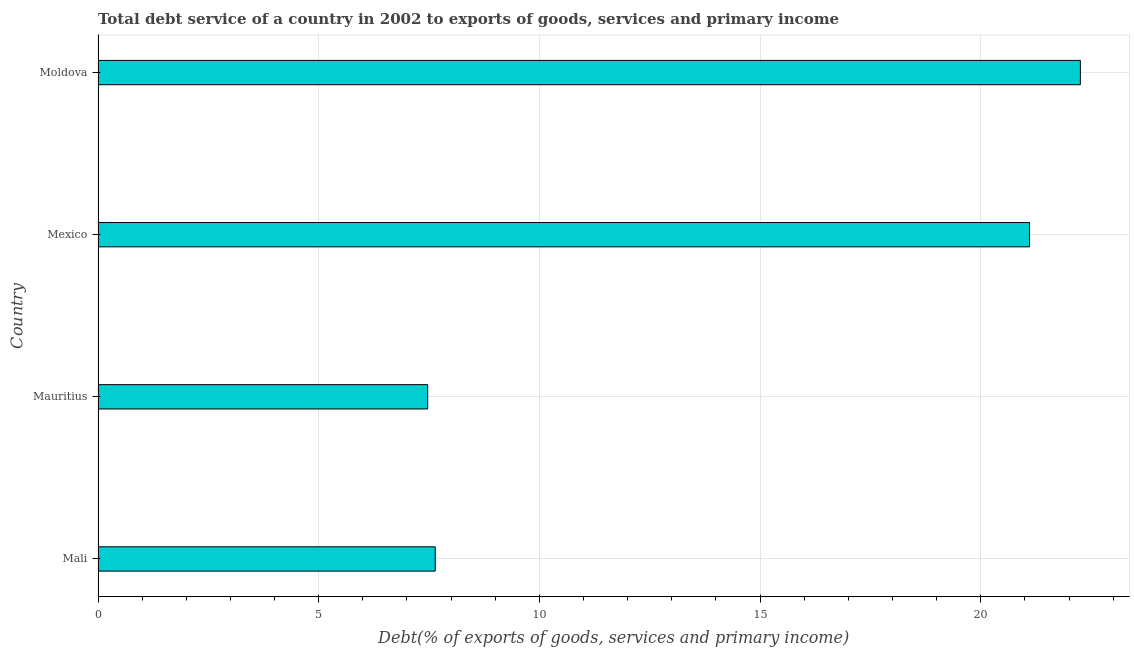Does the graph contain grids?
Give a very brief answer. Yes. What is the title of the graph?
Ensure brevity in your answer.  Total debt service of a country in 2002 to exports of goods, services and primary income. What is the label or title of the X-axis?
Your response must be concise. Debt(% of exports of goods, services and primary income). What is the total debt service in Mali?
Make the answer very short. 7.64. Across all countries, what is the maximum total debt service?
Offer a terse response. 22.26. Across all countries, what is the minimum total debt service?
Give a very brief answer. 7.47. In which country was the total debt service maximum?
Keep it short and to the point. Moldova. In which country was the total debt service minimum?
Give a very brief answer. Mauritius. What is the sum of the total debt service?
Keep it short and to the point. 58.47. What is the difference between the total debt service in Mali and Moldova?
Ensure brevity in your answer.  -14.62. What is the average total debt service per country?
Provide a short and direct response. 14.62. What is the median total debt service?
Give a very brief answer. 14.37. In how many countries, is the total debt service greater than 8 %?
Provide a succinct answer. 2. What is the ratio of the total debt service in Mauritius to that in Moldova?
Your response must be concise. 0.34. Is the difference between the total debt service in Mali and Moldova greater than the difference between any two countries?
Keep it short and to the point. No. What is the difference between the highest and the second highest total debt service?
Your answer should be very brief. 1.15. What is the difference between the highest and the lowest total debt service?
Provide a short and direct response. 14.79. Are all the bars in the graph horizontal?
Make the answer very short. Yes. How many countries are there in the graph?
Your response must be concise. 4. What is the difference between two consecutive major ticks on the X-axis?
Your answer should be very brief. 5. Are the values on the major ticks of X-axis written in scientific E-notation?
Offer a terse response. No. What is the Debt(% of exports of goods, services and primary income) in Mali?
Give a very brief answer. 7.64. What is the Debt(% of exports of goods, services and primary income) in Mauritius?
Your answer should be very brief. 7.47. What is the Debt(% of exports of goods, services and primary income) of Mexico?
Give a very brief answer. 21.11. What is the Debt(% of exports of goods, services and primary income) in Moldova?
Ensure brevity in your answer.  22.26. What is the difference between the Debt(% of exports of goods, services and primary income) in Mali and Mauritius?
Give a very brief answer. 0.17. What is the difference between the Debt(% of exports of goods, services and primary income) in Mali and Mexico?
Give a very brief answer. -13.47. What is the difference between the Debt(% of exports of goods, services and primary income) in Mali and Moldova?
Your answer should be compact. -14.62. What is the difference between the Debt(% of exports of goods, services and primary income) in Mauritius and Mexico?
Ensure brevity in your answer.  -13.64. What is the difference between the Debt(% of exports of goods, services and primary income) in Mauritius and Moldova?
Keep it short and to the point. -14.79. What is the difference between the Debt(% of exports of goods, services and primary income) in Mexico and Moldova?
Make the answer very short. -1.15. What is the ratio of the Debt(% of exports of goods, services and primary income) in Mali to that in Mauritius?
Your response must be concise. 1.02. What is the ratio of the Debt(% of exports of goods, services and primary income) in Mali to that in Mexico?
Your answer should be compact. 0.36. What is the ratio of the Debt(% of exports of goods, services and primary income) in Mali to that in Moldova?
Your response must be concise. 0.34. What is the ratio of the Debt(% of exports of goods, services and primary income) in Mauritius to that in Mexico?
Offer a very short reply. 0.35. What is the ratio of the Debt(% of exports of goods, services and primary income) in Mauritius to that in Moldova?
Offer a very short reply. 0.34. What is the ratio of the Debt(% of exports of goods, services and primary income) in Mexico to that in Moldova?
Give a very brief answer. 0.95. 